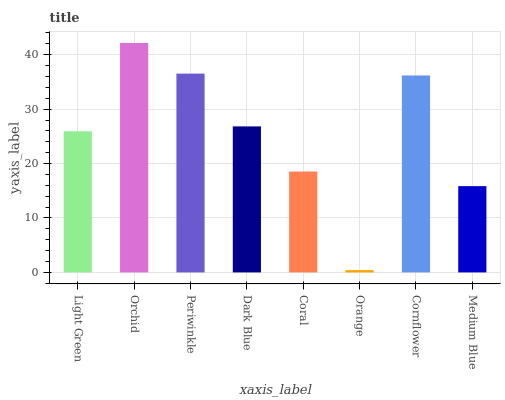Is Orange the minimum?
Answer yes or no. Yes. Is Orchid the maximum?
Answer yes or no. Yes. Is Periwinkle the minimum?
Answer yes or no. No. Is Periwinkle the maximum?
Answer yes or no. No. Is Orchid greater than Periwinkle?
Answer yes or no. Yes. Is Periwinkle less than Orchid?
Answer yes or no. Yes. Is Periwinkle greater than Orchid?
Answer yes or no. No. Is Orchid less than Periwinkle?
Answer yes or no. No. Is Dark Blue the high median?
Answer yes or no. Yes. Is Light Green the low median?
Answer yes or no. Yes. Is Light Green the high median?
Answer yes or no. No. Is Orange the low median?
Answer yes or no. No. 